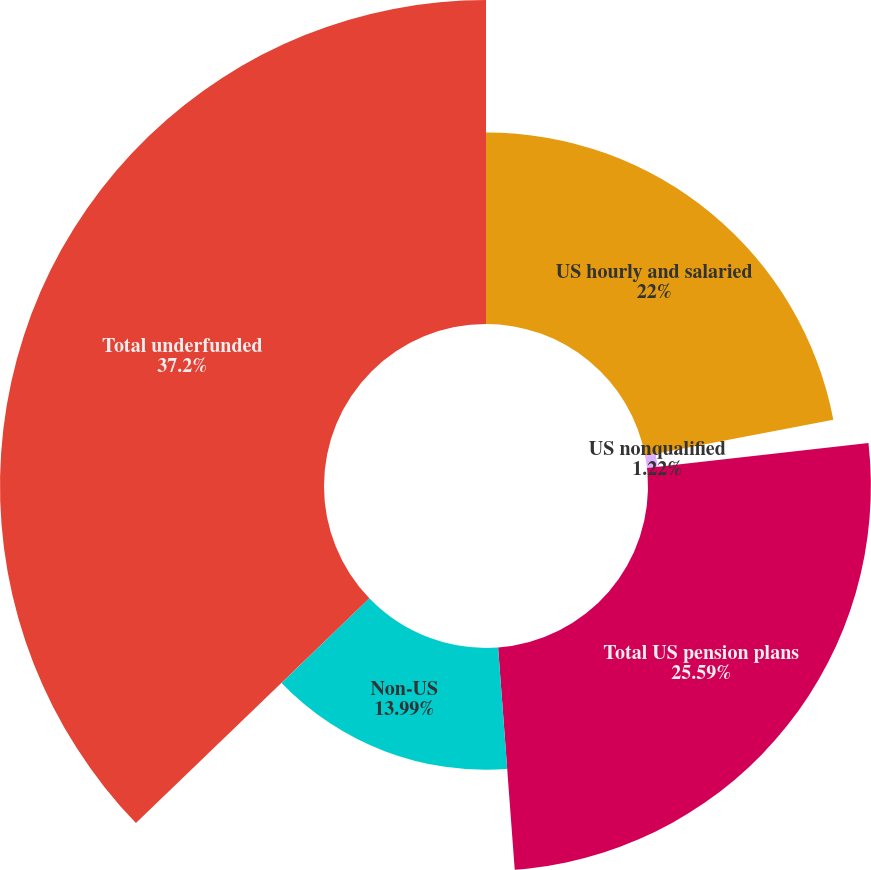Convert chart. <chart><loc_0><loc_0><loc_500><loc_500><pie_chart><fcel>US hourly and salaried<fcel>US nonqualified<fcel>Total US pension plans<fcel>Non-US<fcel>Total underfunded<nl><fcel>22.0%<fcel>1.22%<fcel>25.59%<fcel>13.99%<fcel>37.2%<nl></chart> 